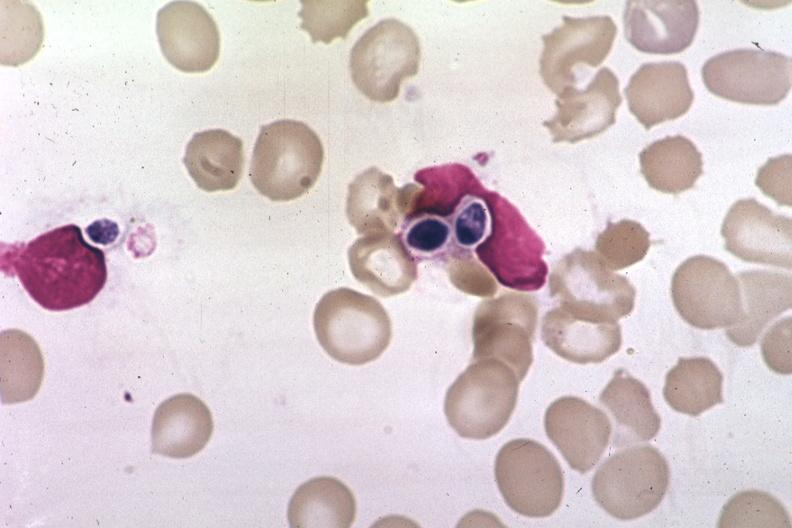s nodule present?
Answer the question using a single word or phrase. No 